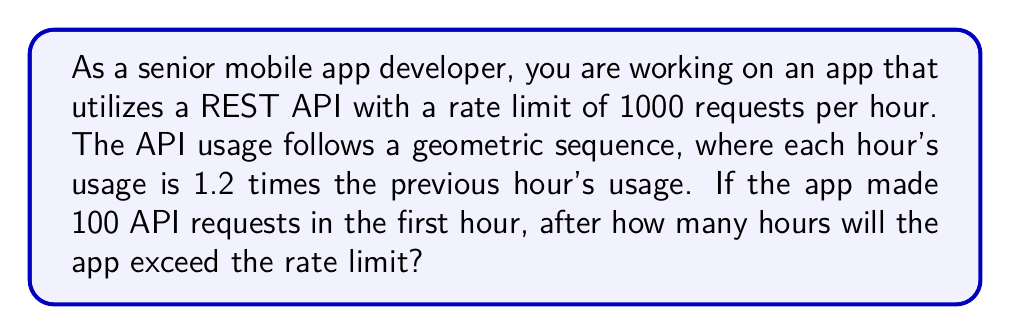Help me with this question. Let's approach this step-by-step:

1) We're dealing with a geometric sequence where:
   - First term, $a = 100$ (initial requests)
   - Common ratio, $r = 1.2$ (each hour's usage is 1.2 times the previous)

2) The general term of a geometric sequence is given by:
   $a_n = ar^{n-1}$
   Where $n$ is the hour number.

3) We need to find $n$ where $a_n$ exceeds 1000. So, we set up the inequality:
   $100 \cdot 1.2^{n-1} > 1000$

4) Solving the inequality:
   $1.2^{n-1} > 10$
   
   Taking $\log$ of both sides (we can use any base, let's use base 10):
   $\log(1.2^{n-1}) > \log(10)$
   $(n-1)\log(1.2) > 1$
   
   $n-1 > \frac{1}{\log(1.2)}$
   $n > \frac{1}{\log(1.2)} + 1$

5) Using a calculator or computer:
   $\frac{1}{\log(1.2)} + 1 \approx 13.513$

6) Since $n$ represents hours and must be a whole number, we need to round up to the next integer.
Answer: The app will exceed the rate limit after 14 hours. 